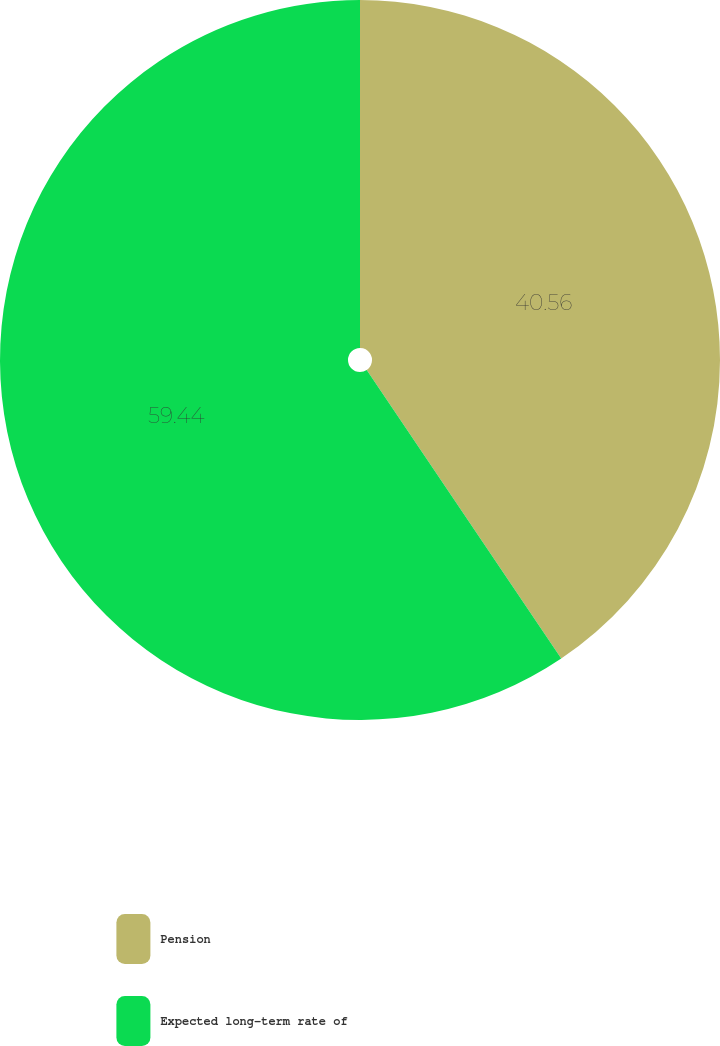<chart> <loc_0><loc_0><loc_500><loc_500><pie_chart><fcel>Pension<fcel>Expected long-term rate of<nl><fcel>40.56%<fcel>59.44%<nl></chart> 